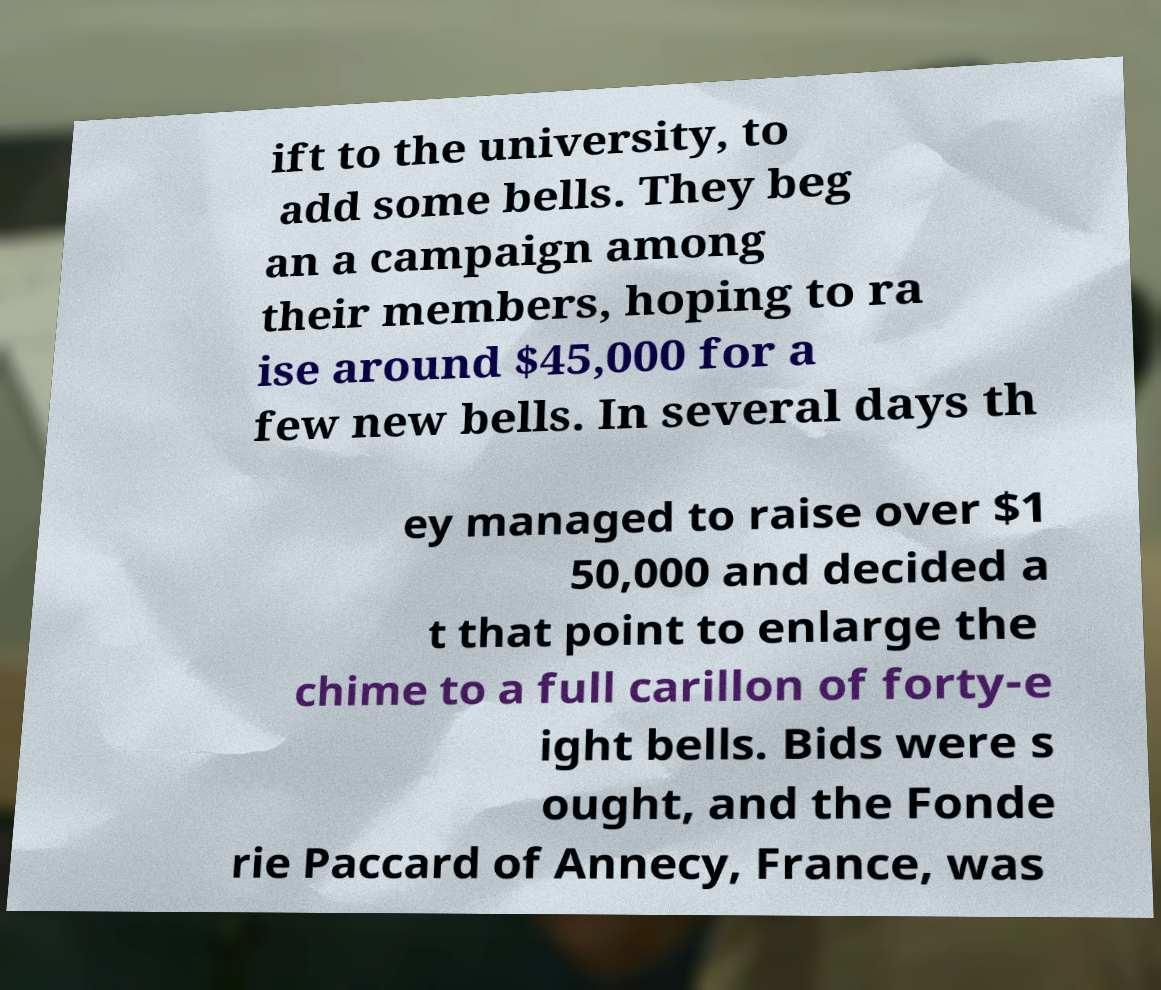Please read and relay the text visible in this image. What does it say? ift to the university, to add some bells. They beg an a campaign among their members, hoping to ra ise around $45,000 for a few new bells. In several days th ey managed to raise over $1 50,000 and decided a t that point to enlarge the chime to a full carillon of forty-e ight bells. Bids were s ought, and the Fonde rie Paccard of Annecy, France, was 